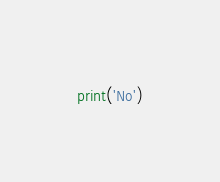<code> <loc_0><loc_0><loc_500><loc_500><_Python_>print('No')</code> 